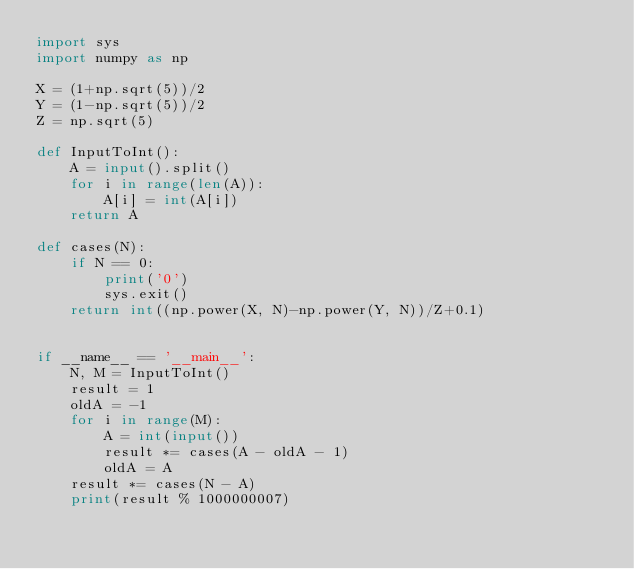Convert code to text. <code><loc_0><loc_0><loc_500><loc_500><_Python_>import sys
import numpy as np

X = (1+np.sqrt(5))/2
Y = (1-np.sqrt(5))/2
Z = np.sqrt(5)

def InputToInt():
    A = input().split()
    for i in range(len(A)):
        A[i] = int(A[i])
    return A

def cases(N):
    if N == 0:
        print('0')
        sys.exit()
    return int((np.power(X, N)-np.power(Y, N))/Z+0.1)
    
    
if __name__ == '__main__':
    N, M = InputToInt()
    result = 1
    oldA = -1
    for i in range(M):
        A = int(input())
        result *= cases(A - oldA - 1)
        oldA = A
    result *= cases(N - A)
    print(result % 1000000007)
</code> 